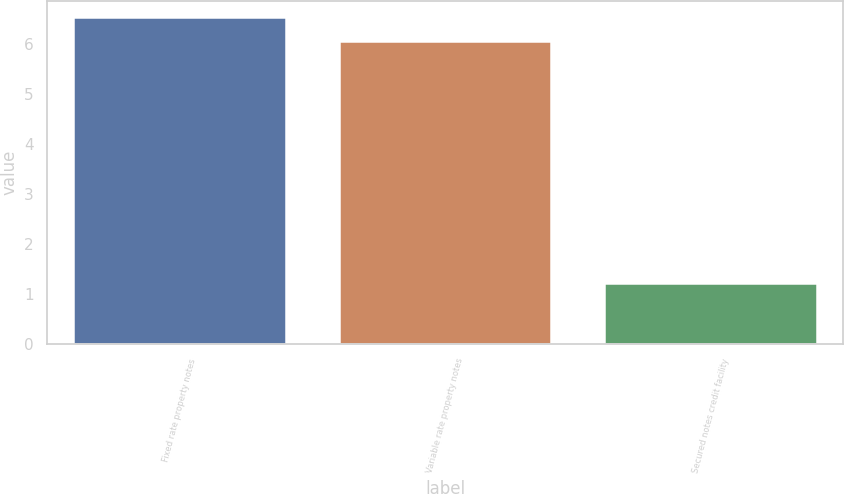Convert chart to OTSL. <chart><loc_0><loc_0><loc_500><loc_500><bar_chart><fcel>Fixed rate property notes<fcel>Variable rate property notes<fcel>Secured notes credit facility<nl><fcel>6.53<fcel>6.05<fcel>1.22<nl></chart> 